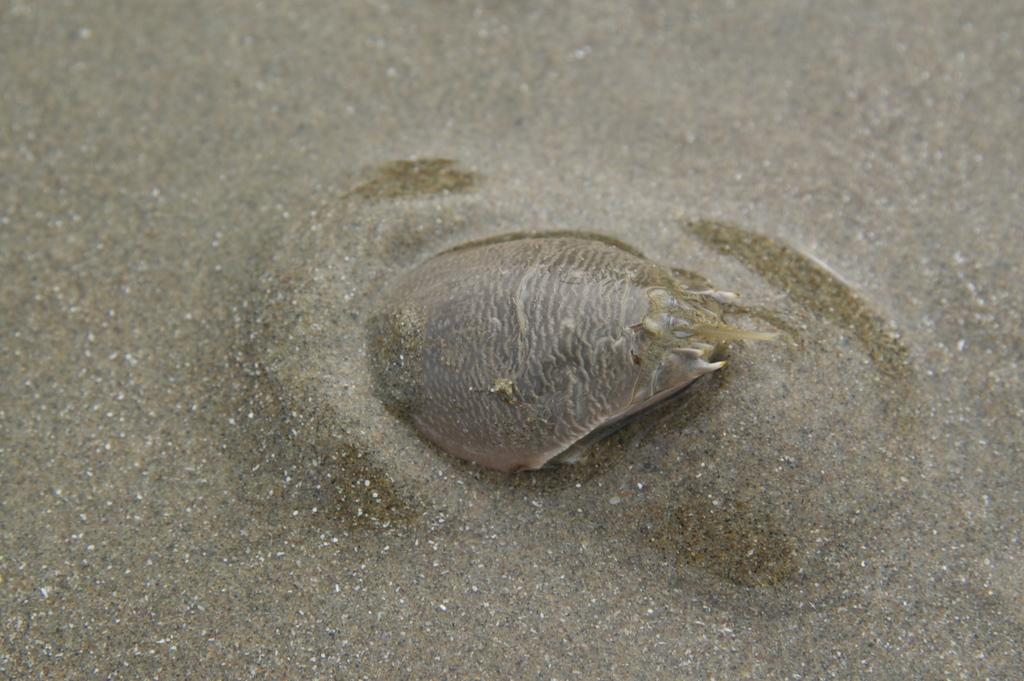What type of animal can be seen in the image? There is a sea animal in the image. Where is the sea animal located? The sea animal is in the water. What type of street is visible in the image? There is no street present in the image; it features a sea animal in the water. How many men are playing in the image? There are no men or any play-related activities depicted in the image. 